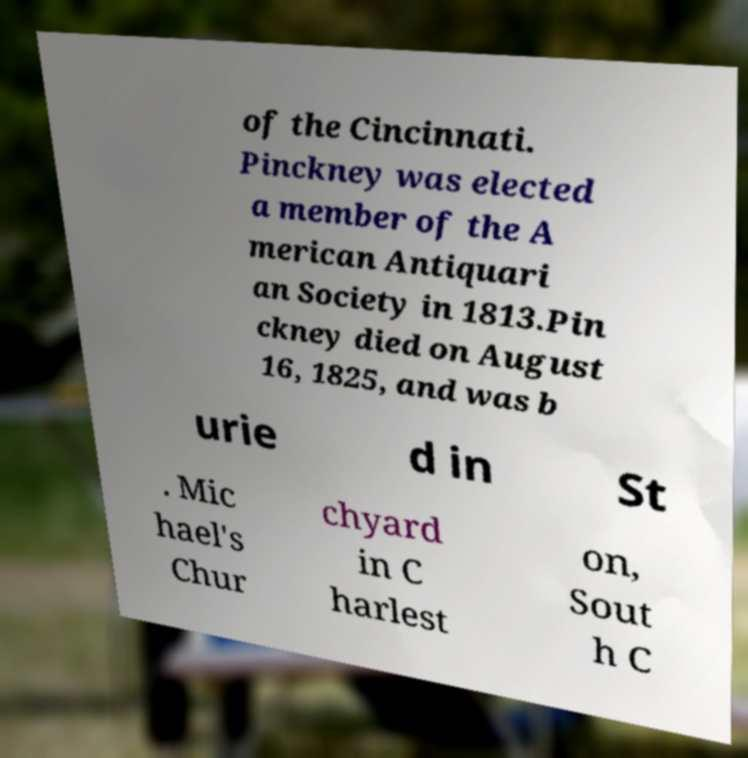There's text embedded in this image that I need extracted. Can you transcribe it verbatim? of the Cincinnati. Pinckney was elected a member of the A merican Antiquari an Society in 1813.Pin ckney died on August 16, 1825, and was b urie d in St . Mic hael's Chur chyard in C harlest on, Sout h C 